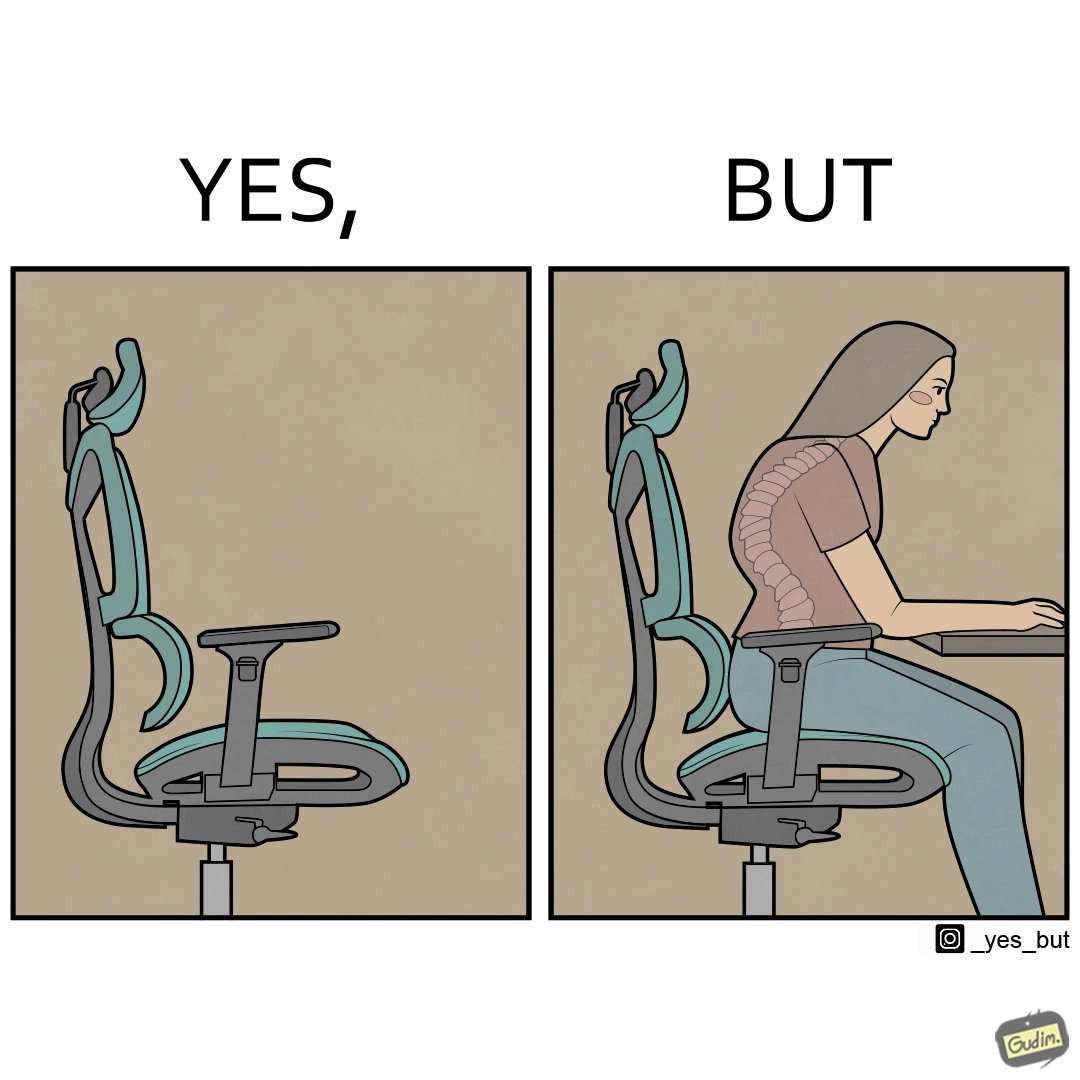Describe what you see in this image. The image is ironical, as even though the ergonomic chair is meant to facilitate an upright and comfortable posture for the person sitting on it, the person sitting on it still has a bent posture, as the person is not utilizing the backrest. 